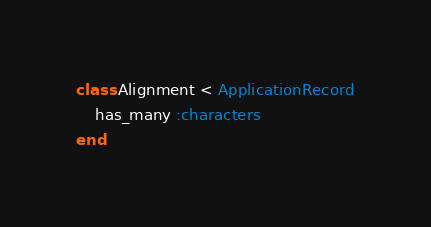Convert code to text. <code><loc_0><loc_0><loc_500><loc_500><_Ruby_>class Alignment < ApplicationRecord
    has_many :characters
end
</code> 